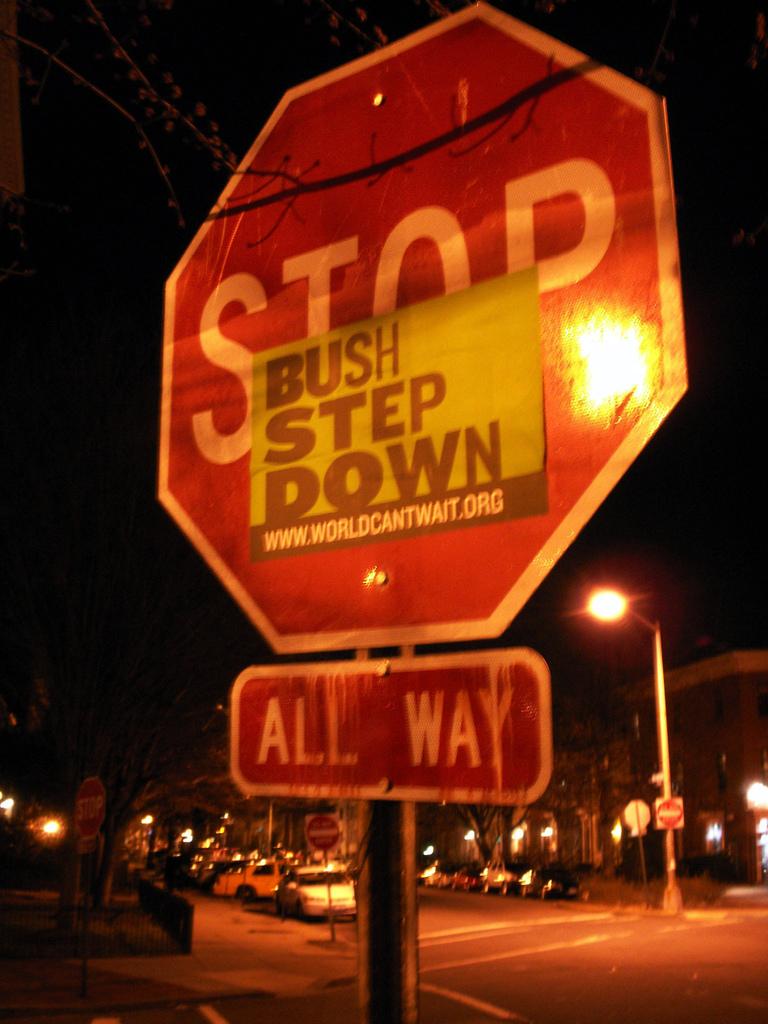What kind of sign is this?
Your answer should be very brief. Stop. Who do they want to step down?
Provide a succinct answer. Bush. 